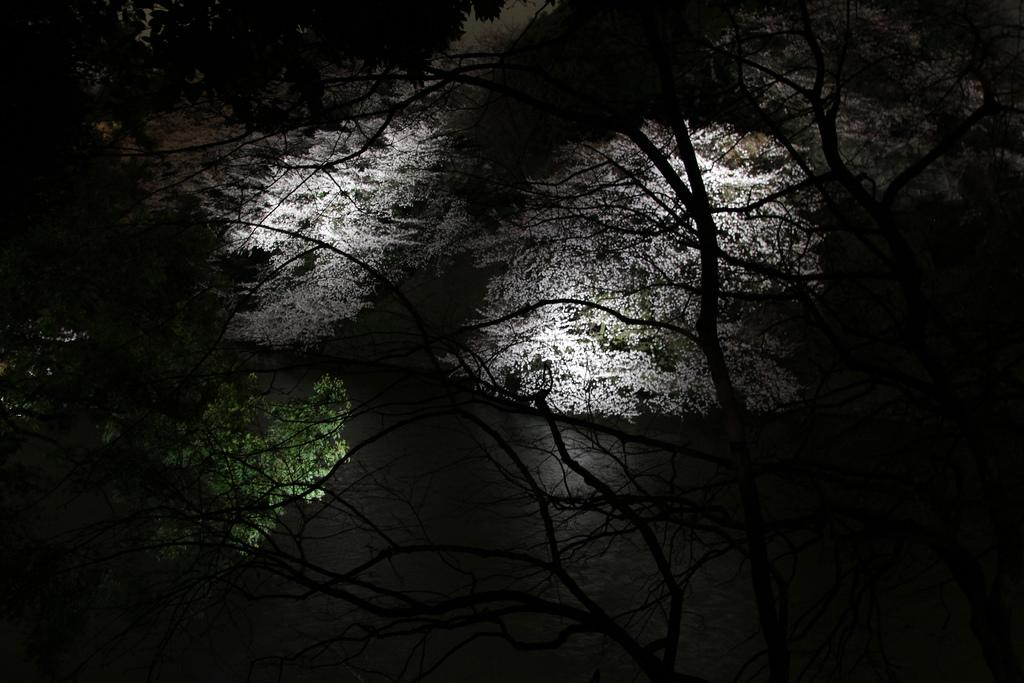What is the primary feature of the image? There are many trees in the image. What can be seen at the bottom of the image? There is water at the bottom of the image. What is visible in the front of the image? Rays of light are visible in the front of the image. What type of scissors can be seen cutting the trees in the image? There are no scissors present in the image, and the trees are not being cut. 